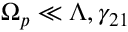<formula> <loc_0><loc_0><loc_500><loc_500>\Omega _ { p } \ll \Lambda , \gamma _ { 2 1 }</formula> 